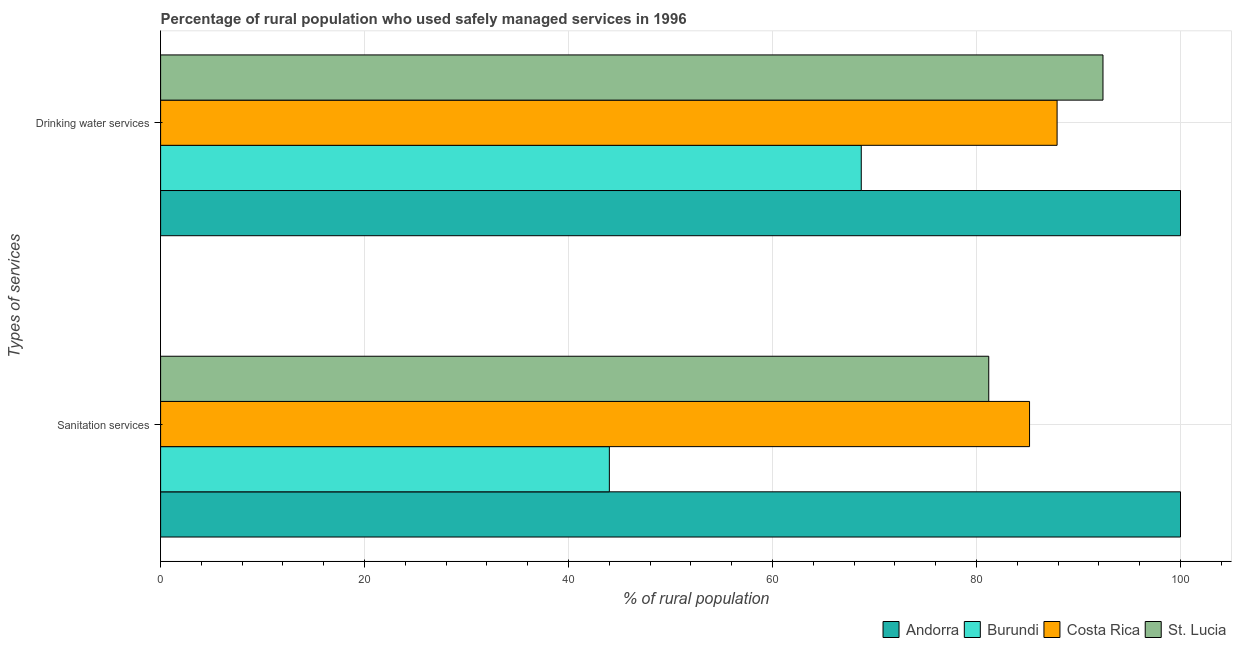How many groups of bars are there?
Offer a terse response. 2. Are the number of bars on each tick of the Y-axis equal?
Keep it short and to the point. Yes. How many bars are there on the 1st tick from the top?
Make the answer very short. 4. How many bars are there on the 1st tick from the bottom?
Make the answer very short. 4. What is the label of the 1st group of bars from the top?
Make the answer very short. Drinking water services. What is the percentage of rural population who used drinking water services in Andorra?
Offer a terse response. 100. Across all countries, what is the minimum percentage of rural population who used drinking water services?
Ensure brevity in your answer.  68.7. In which country was the percentage of rural population who used sanitation services maximum?
Your answer should be very brief. Andorra. In which country was the percentage of rural population who used drinking water services minimum?
Provide a short and direct response. Burundi. What is the total percentage of rural population who used drinking water services in the graph?
Provide a succinct answer. 349. What is the difference between the percentage of rural population who used sanitation services in Burundi and that in St. Lucia?
Your answer should be very brief. -37.2. What is the difference between the percentage of rural population who used drinking water services in Burundi and the percentage of rural population who used sanitation services in Andorra?
Ensure brevity in your answer.  -31.3. What is the average percentage of rural population who used sanitation services per country?
Your answer should be very brief. 77.6. What is the ratio of the percentage of rural population who used drinking water services in Burundi to that in St. Lucia?
Provide a succinct answer. 0.74. What does the 4th bar from the bottom in Sanitation services represents?
Make the answer very short. St. Lucia. How many countries are there in the graph?
Your answer should be very brief. 4. How are the legend labels stacked?
Make the answer very short. Horizontal. What is the title of the graph?
Your answer should be very brief. Percentage of rural population who used safely managed services in 1996. What is the label or title of the X-axis?
Ensure brevity in your answer.  % of rural population. What is the label or title of the Y-axis?
Offer a very short reply. Types of services. What is the % of rural population in Andorra in Sanitation services?
Keep it short and to the point. 100. What is the % of rural population in Costa Rica in Sanitation services?
Provide a succinct answer. 85.2. What is the % of rural population of St. Lucia in Sanitation services?
Your response must be concise. 81.2. What is the % of rural population of Andorra in Drinking water services?
Make the answer very short. 100. What is the % of rural population of Burundi in Drinking water services?
Your response must be concise. 68.7. What is the % of rural population in Costa Rica in Drinking water services?
Your response must be concise. 87.9. What is the % of rural population in St. Lucia in Drinking water services?
Make the answer very short. 92.4. Across all Types of services, what is the maximum % of rural population of Burundi?
Your answer should be compact. 68.7. Across all Types of services, what is the maximum % of rural population in Costa Rica?
Ensure brevity in your answer.  87.9. Across all Types of services, what is the maximum % of rural population in St. Lucia?
Offer a very short reply. 92.4. Across all Types of services, what is the minimum % of rural population in Andorra?
Your response must be concise. 100. Across all Types of services, what is the minimum % of rural population in Costa Rica?
Offer a terse response. 85.2. Across all Types of services, what is the minimum % of rural population in St. Lucia?
Offer a terse response. 81.2. What is the total % of rural population in Burundi in the graph?
Offer a very short reply. 112.7. What is the total % of rural population in Costa Rica in the graph?
Ensure brevity in your answer.  173.1. What is the total % of rural population in St. Lucia in the graph?
Keep it short and to the point. 173.6. What is the difference between the % of rural population of Burundi in Sanitation services and that in Drinking water services?
Your answer should be very brief. -24.7. What is the difference between the % of rural population of Costa Rica in Sanitation services and that in Drinking water services?
Your response must be concise. -2.7. What is the difference between the % of rural population of St. Lucia in Sanitation services and that in Drinking water services?
Offer a terse response. -11.2. What is the difference between the % of rural population of Andorra in Sanitation services and the % of rural population of Burundi in Drinking water services?
Ensure brevity in your answer.  31.3. What is the difference between the % of rural population of Andorra in Sanitation services and the % of rural population of St. Lucia in Drinking water services?
Offer a very short reply. 7.6. What is the difference between the % of rural population of Burundi in Sanitation services and the % of rural population of Costa Rica in Drinking water services?
Provide a succinct answer. -43.9. What is the difference between the % of rural population of Burundi in Sanitation services and the % of rural population of St. Lucia in Drinking water services?
Provide a succinct answer. -48.4. What is the difference between the % of rural population of Costa Rica in Sanitation services and the % of rural population of St. Lucia in Drinking water services?
Keep it short and to the point. -7.2. What is the average % of rural population of Burundi per Types of services?
Provide a short and direct response. 56.35. What is the average % of rural population in Costa Rica per Types of services?
Provide a short and direct response. 86.55. What is the average % of rural population of St. Lucia per Types of services?
Ensure brevity in your answer.  86.8. What is the difference between the % of rural population in Andorra and % of rural population in St. Lucia in Sanitation services?
Your answer should be very brief. 18.8. What is the difference between the % of rural population in Burundi and % of rural population in Costa Rica in Sanitation services?
Make the answer very short. -41.2. What is the difference between the % of rural population in Burundi and % of rural population in St. Lucia in Sanitation services?
Your answer should be very brief. -37.2. What is the difference between the % of rural population in Andorra and % of rural population in Burundi in Drinking water services?
Keep it short and to the point. 31.3. What is the difference between the % of rural population in Burundi and % of rural population in Costa Rica in Drinking water services?
Ensure brevity in your answer.  -19.2. What is the difference between the % of rural population of Burundi and % of rural population of St. Lucia in Drinking water services?
Offer a very short reply. -23.7. What is the difference between the % of rural population in Costa Rica and % of rural population in St. Lucia in Drinking water services?
Your response must be concise. -4.5. What is the ratio of the % of rural population in Burundi in Sanitation services to that in Drinking water services?
Your answer should be very brief. 0.64. What is the ratio of the % of rural population in Costa Rica in Sanitation services to that in Drinking water services?
Provide a short and direct response. 0.97. What is the ratio of the % of rural population in St. Lucia in Sanitation services to that in Drinking water services?
Your answer should be very brief. 0.88. What is the difference between the highest and the second highest % of rural population in Andorra?
Your response must be concise. 0. What is the difference between the highest and the second highest % of rural population of Burundi?
Give a very brief answer. 24.7. What is the difference between the highest and the lowest % of rural population in Andorra?
Your response must be concise. 0. What is the difference between the highest and the lowest % of rural population of Burundi?
Give a very brief answer. 24.7. 